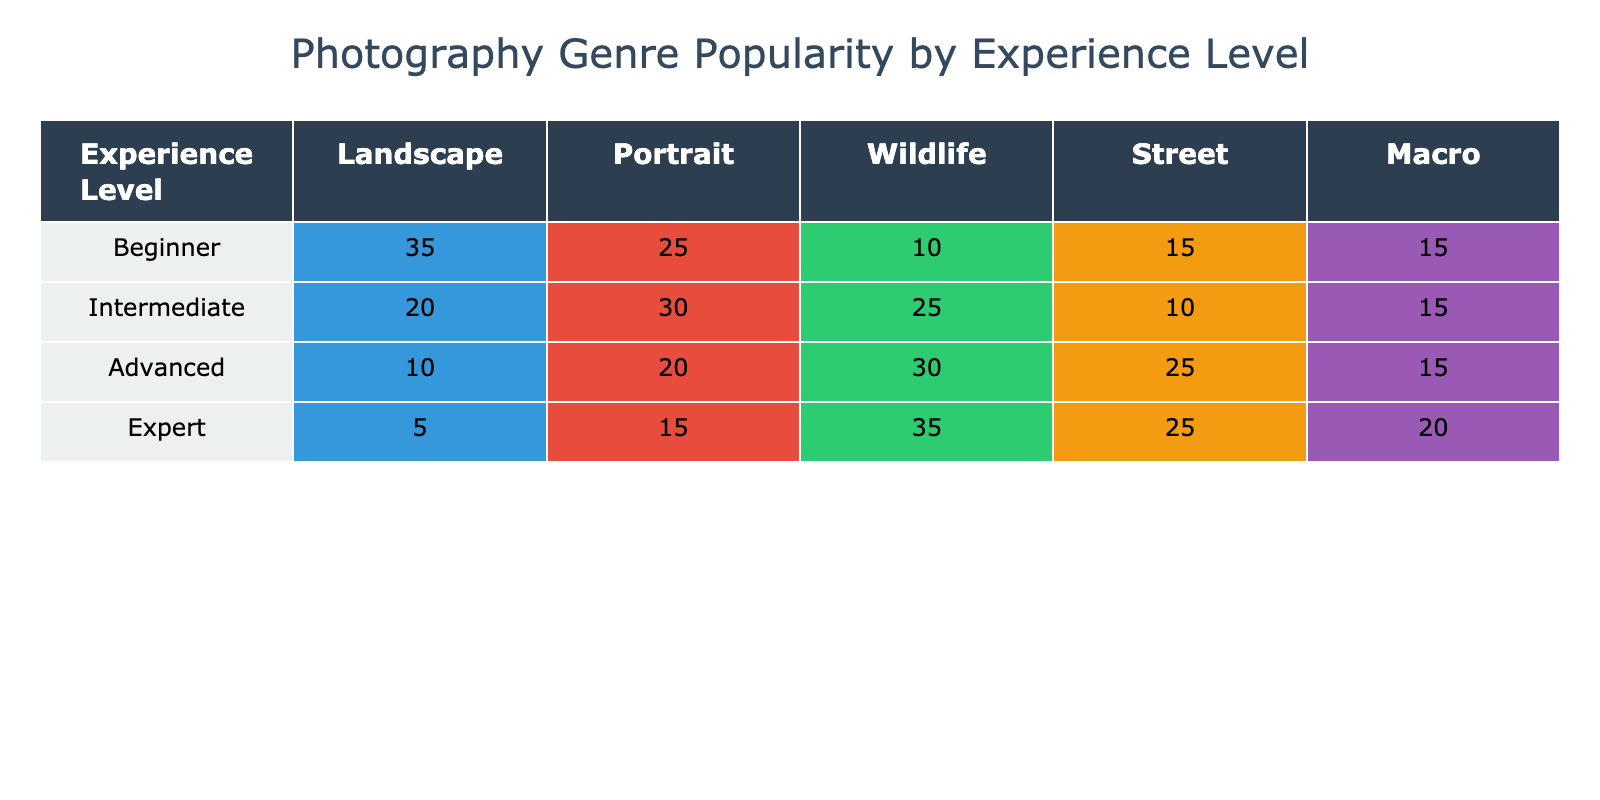What is the most popular photography genre among beginners? Looking at the 'Beginner' row, the highest number in the popularity column is 35, which belongs to Landscape photography.
Answer: Landscape Which photography genre has the least popularity among advanced photographers? In the 'Advanced' row, the lowest value is 10, which is for Landscape photography.
Answer: Landscape What is the total popularity score for Wildlife photography across all experience levels? To find the total, add the Wildlife values: 10 (Beginner) + 25 (Intermediate) + 30 (Advanced) + 35 (Expert) = 100.
Answer: 100 True or false: Street photography is more popular than Macro photography for intermediate photographers. In the 'Intermediate' row, Street has a popularity of 10, while Macro has 15, making the statement false.
Answer: False What is the difference in popularity for Portrait photography between experts and intermediates? For Experts, the popularity for Portrait is 15, and for Intermediates, it is 30. The difference is 30 - 15 = 15.
Answer: 15 Which experience level has the highest total combined popularity across all photography genres? Calculate the total for each level: Beginner (35 + 25 + 10 + 15 + 15 = 100), Intermediate (20 + 30 + 25 + 10 + 15 = 100), Advanced (10 + 20 + 30 + 25 + 15 = 100), Expert (5 + 15 + 35 + 25 + 20 = 100). All levels have the same total of 100.
Answer: All levels What percentage of advanced photographers prefer Wildlife photography? Advanced Wildlife popularity is 30, so to find the percentage: (30 / (10 + 20 + 30 + 25 + 15)) * 100 = (30 / 100) * 100 = 30%.
Answer: 30% Is Macro photography the least popular genre among experts? In the 'Expert' row, Macro has a popularity of 20, while Landscape has 5 and is lower. Thus, Macro is not the least popular.
Answer: No How does the popularity of Portrait photography change from beginners to experts? Beginners have 25, and experts have 15. The change is a decrease of 10 from 25 to 15.
Answer: Decrease of 10 